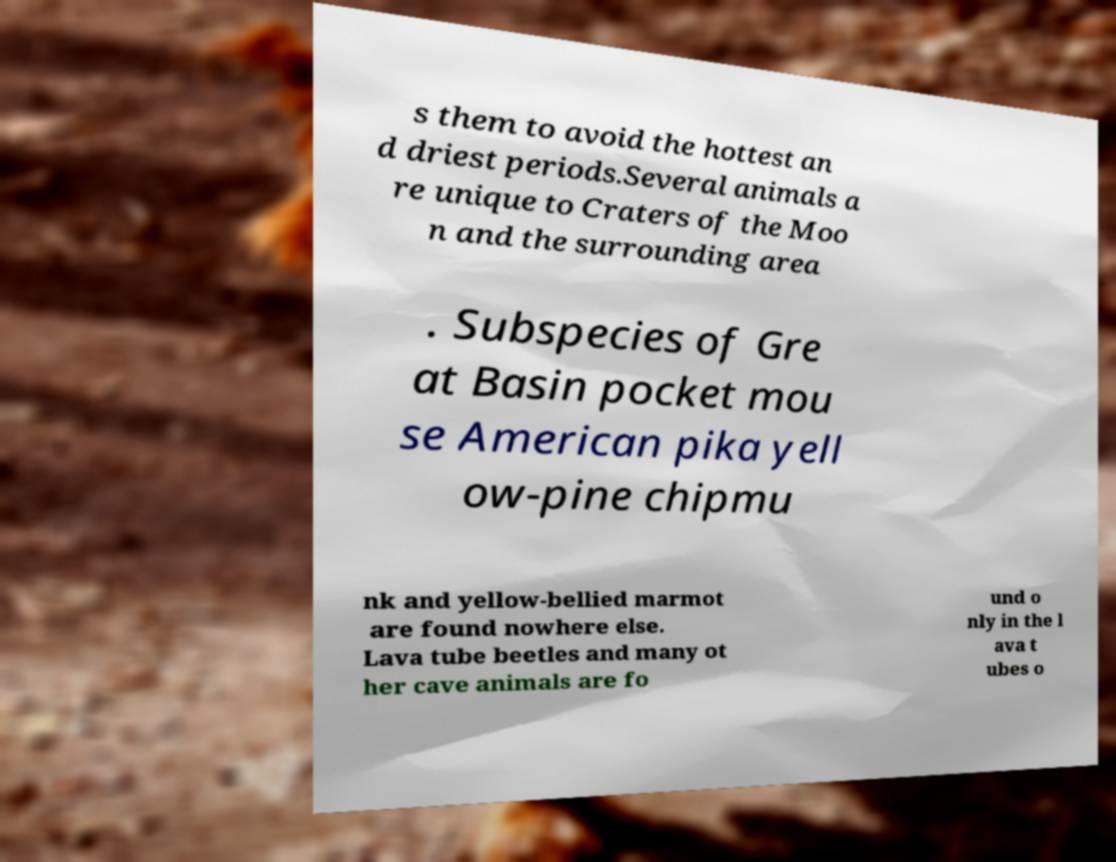For documentation purposes, I need the text within this image transcribed. Could you provide that? s them to avoid the hottest an d driest periods.Several animals a re unique to Craters of the Moo n and the surrounding area . Subspecies of Gre at Basin pocket mou se American pika yell ow-pine chipmu nk and yellow-bellied marmot are found nowhere else. Lava tube beetles and many ot her cave animals are fo und o nly in the l ava t ubes o 